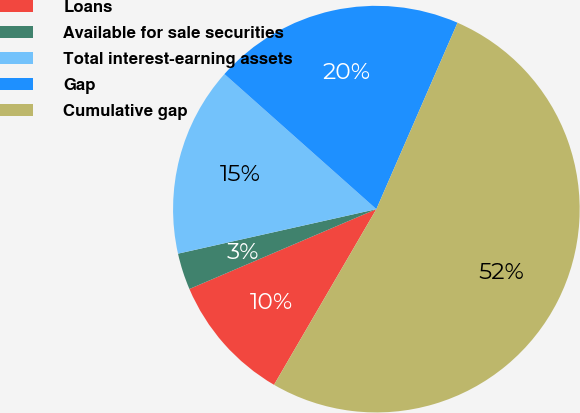Convert chart. <chart><loc_0><loc_0><loc_500><loc_500><pie_chart><fcel>Loans<fcel>Available for sale securities<fcel>Total interest-earning assets<fcel>Gap<fcel>Cumulative gap<nl><fcel>10.18%<fcel>2.91%<fcel>15.08%<fcel>19.97%<fcel>51.86%<nl></chart> 